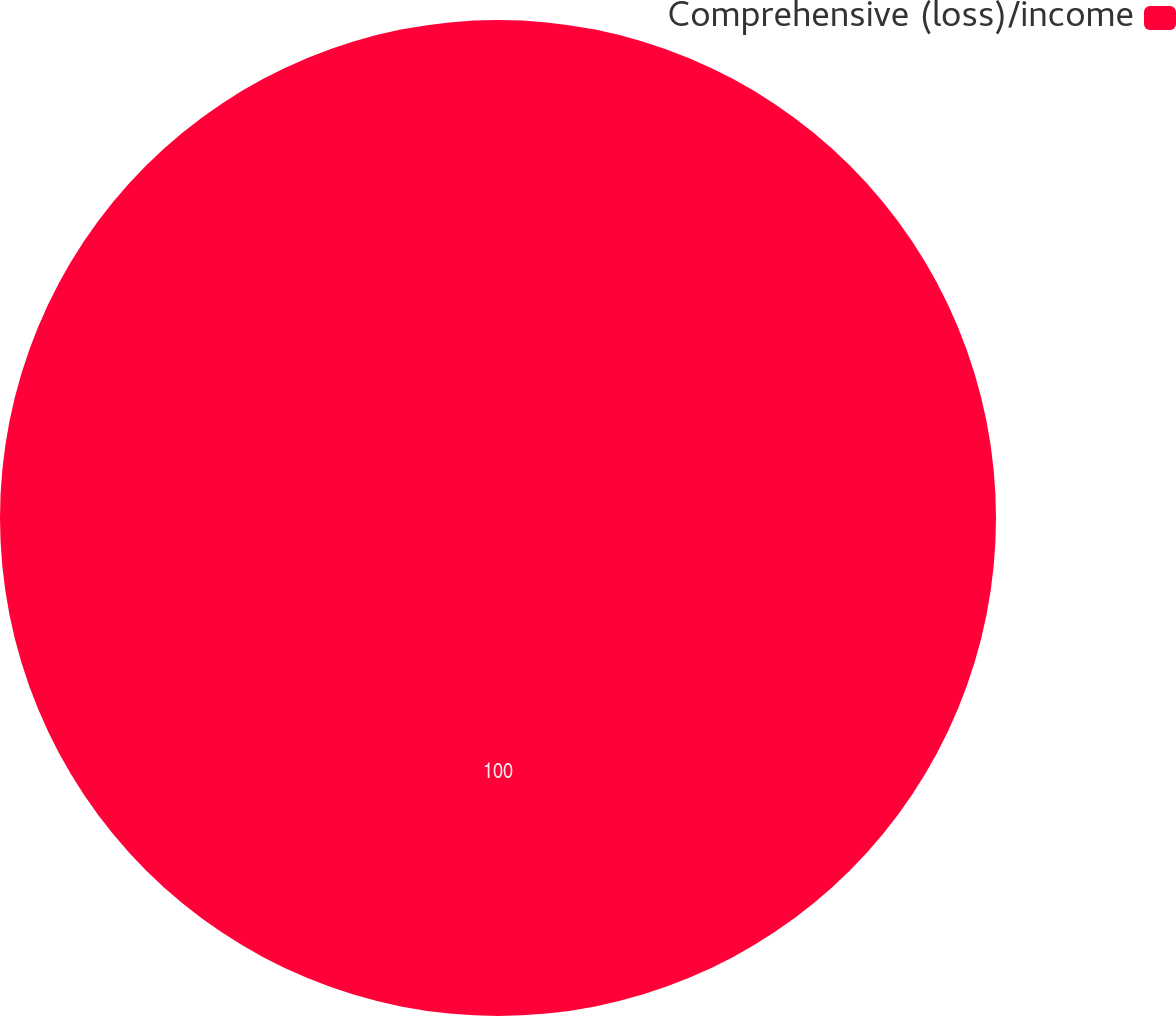Convert chart to OTSL. <chart><loc_0><loc_0><loc_500><loc_500><pie_chart><fcel>Comprehensive (loss)/income<nl><fcel>100.0%<nl></chart> 